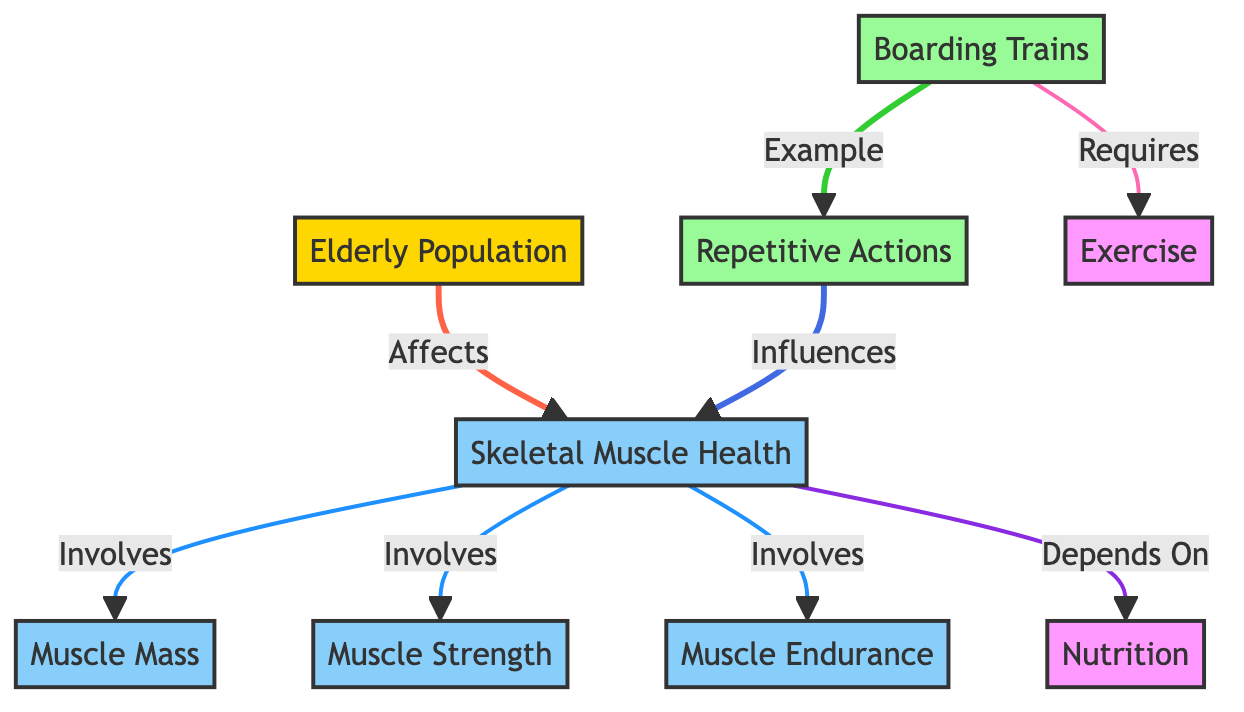What affects Skeletal Muscle Health? According to the diagram, the node "Elderly Population" is directly connected to the "Skeletal Muscle Health" node with the relationship labeled “Affects.” This indicates that the health of skeletal muscles is influenced by the elderly population.
Answer: Elderly Population What influences Skeletal Muscle Health? The diagram shows that "Repetitive Actions" has a directed connection to "Skeletal Muscle Health" labeled “Influences,” which indicates that repetitive actions have an effect on skeletal muscle health.
Answer: Repetitive Actions How many health aspects are involved in Skeletal Muscle Health? The illustration indicates three health aspects: "Muscle Mass," "Muscle Strength," and "Muscle Endurance," each being part of the "Skeletal Muscle Health" node. Therefore, there are three aspects involved.
Answer: 3 What is an example of Repetitive Actions? The diagram directly lists "Boarding Trains" as an example under the "Repetitive Actions" node, linking it to that category.
Answer: Boarding Trains What does boarding trains require? The diagram states that "Boarding Trains" requires "Exercise," as indicated by the directed connection labeled “Requires.” Thus, this action necessitates physical exercise.
Answer: Exercise What does Skeletal Muscle Health depend on? According to the diagram, the "Skeletal Muscle Health" node is connected to the "Nutrition" node with the relationship “Depends On,” signifying that nutrition is an important aspect that the skeletal muscle health relies upon.
Answer: Nutrition How many nodes represent health aspects in this diagram? The diagram includes "Skeletal Muscle Health," "Muscle Mass," "Muscle Strength," and "Muscle Endurance," totaling four nodes representing health aspects.
Answer: 4 What is the relationship between Elderly Population and Skeletal Muscle Health? The diagram clearly indicates a directed connection where "Elderly Population" affects "Skeletal Muscle Health," designated as the relationship labeled “Affects.” This interconnection demonstrates the significant impact of elderly individuals on muscle health.
Answer: Affects What influences repetitive actions? Upon reviewing the flow of the diagram, "Boarding Trains" is shown as a specific example of "Repetitive Actions," therefore, it can be inferred that boarding trains influences the category of repetitive actions.
Answer: Boarding Trains 